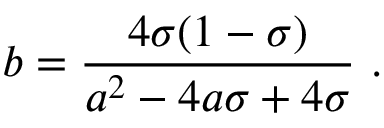Convert formula to latex. <formula><loc_0><loc_0><loc_500><loc_500>{ b } = { \frac { 4 \sigma ( 1 - \sigma ) } { { a } ^ { 2 } - 4 { a } \sigma + 4 \sigma } } \ .</formula> 